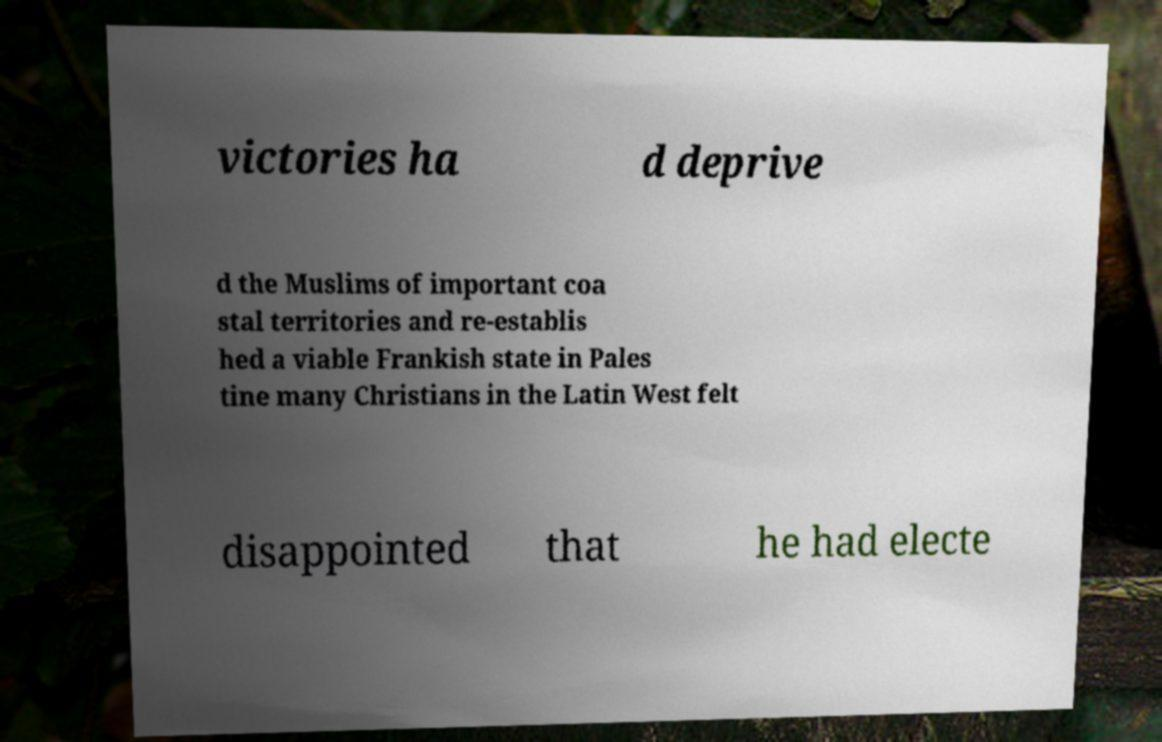Please read and relay the text visible in this image. What does it say? victories ha d deprive d the Muslims of important coa stal territories and re-establis hed a viable Frankish state in Pales tine many Christians in the Latin West felt disappointed that he had electe 